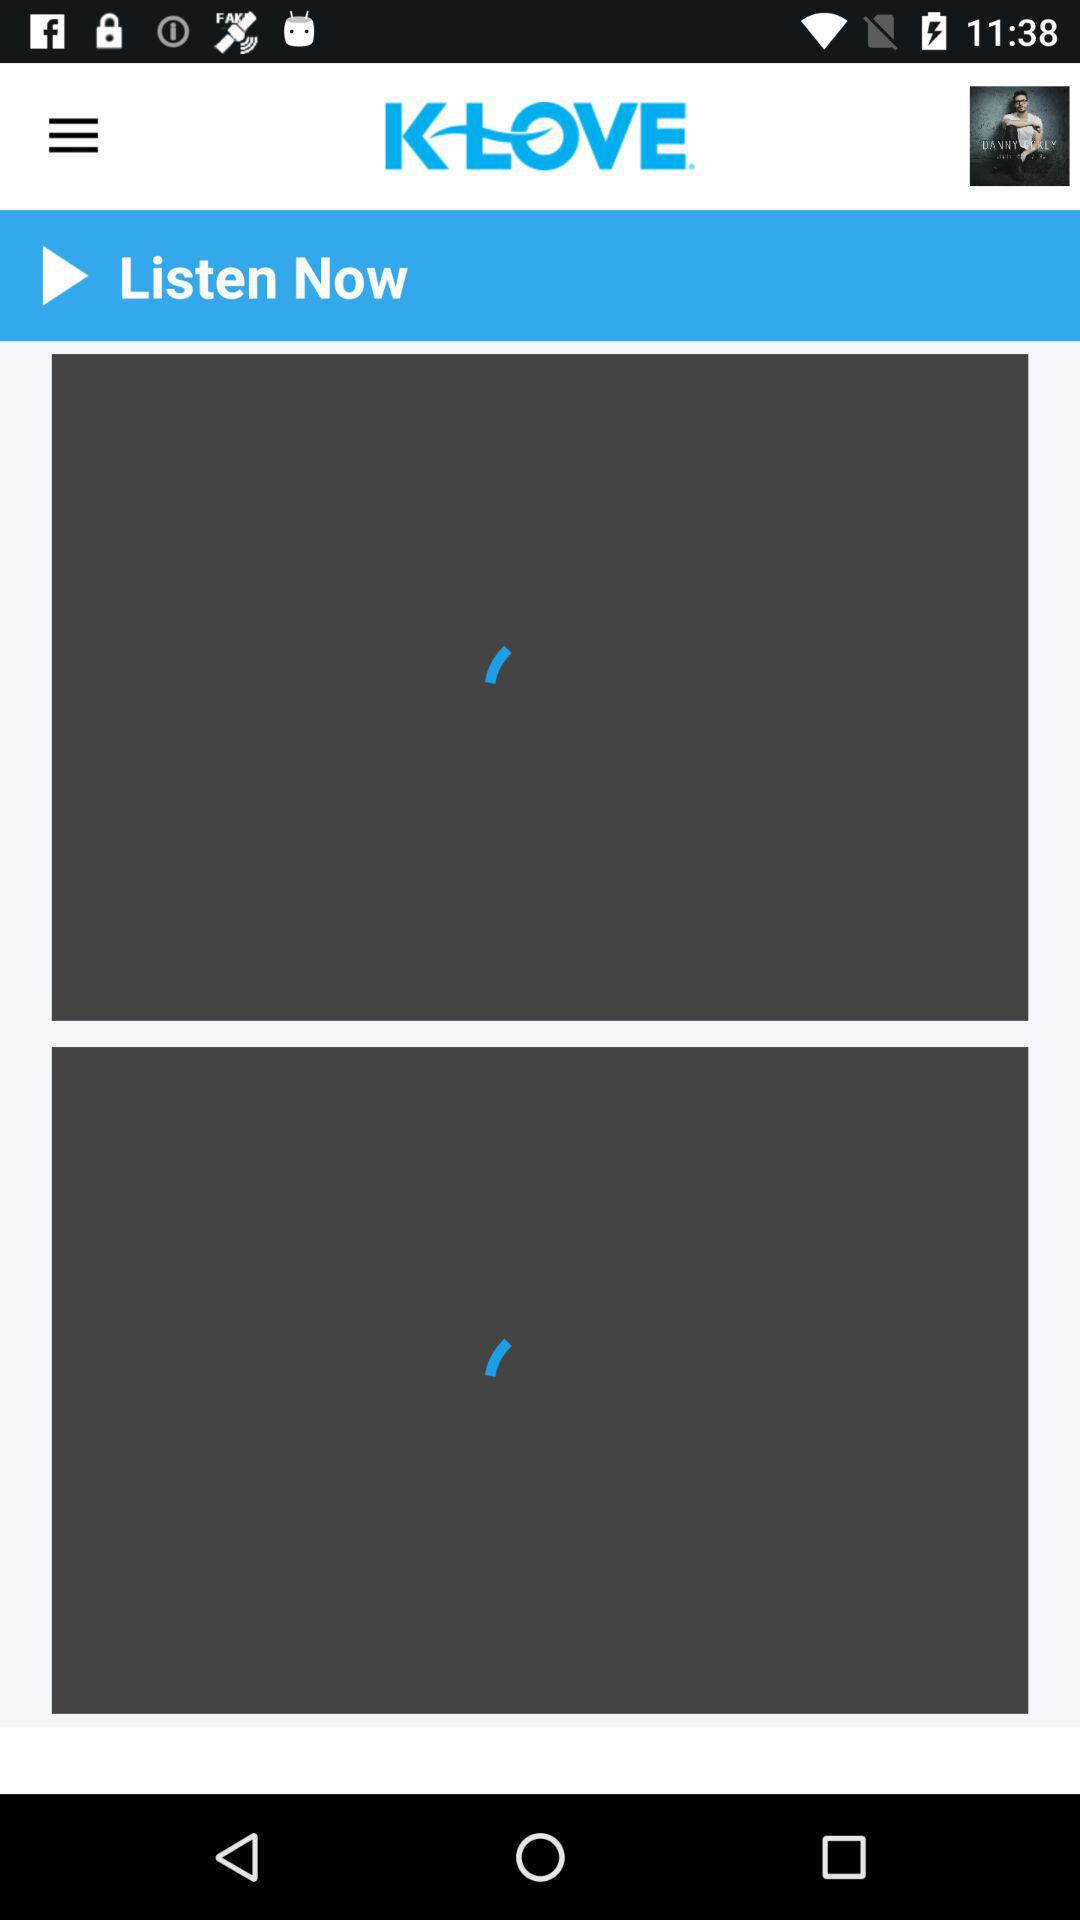What is the name of the application? The name of the application is "KLOVE". 